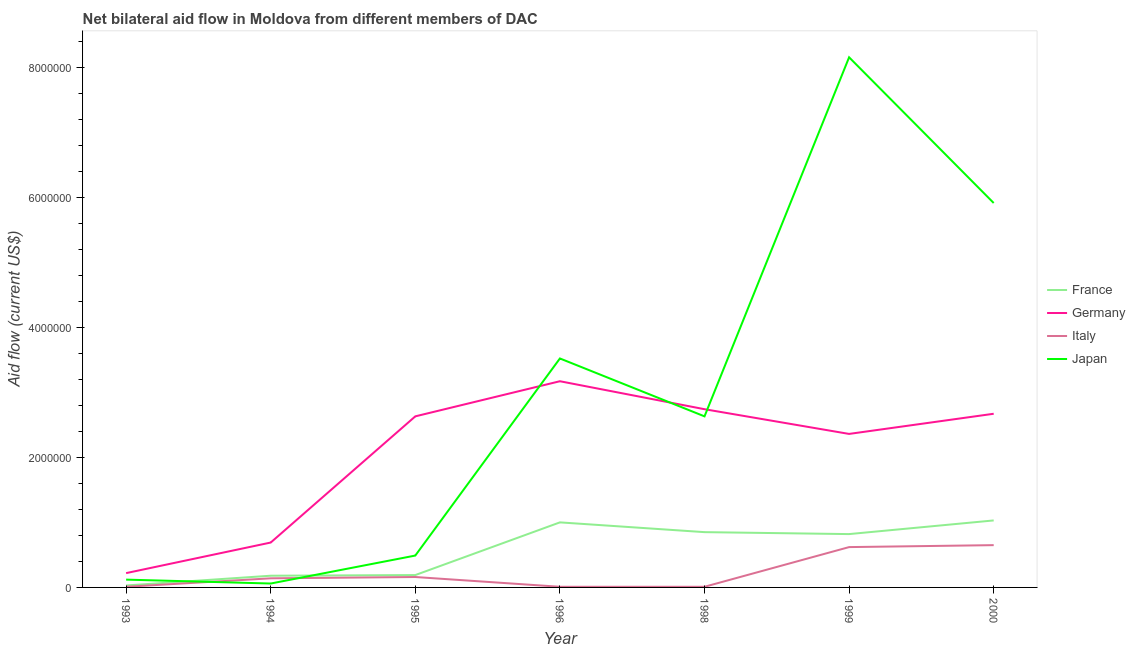What is the amount of aid given by france in 1996?
Ensure brevity in your answer.  1.00e+06. Across all years, what is the maximum amount of aid given by japan?
Your answer should be very brief. 8.15e+06. Across all years, what is the minimum amount of aid given by france?
Ensure brevity in your answer.  3.00e+04. In which year was the amount of aid given by italy maximum?
Offer a terse response. 2000. In which year was the amount of aid given by germany minimum?
Provide a succinct answer. 1993. What is the total amount of aid given by france in the graph?
Offer a terse response. 4.10e+06. What is the difference between the amount of aid given by germany in 1993 and that in 1999?
Provide a short and direct response. -2.14e+06. What is the difference between the amount of aid given by italy in 2000 and the amount of aid given by france in 1998?
Provide a succinct answer. -2.00e+05. What is the average amount of aid given by japan per year?
Your answer should be very brief. 2.98e+06. In the year 2000, what is the difference between the amount of aid given by france and amount of aid given by japan?
Provide a succinct answer. -4.88e+06. What is the ratio of the amount of aid given by germany in 1998 to that in 1999?
Your response must be concise. 1.16. What is the difference between the highest and the second highest amount of aid given by japan?
Your answer should be very brief. 2.24e+06. What is the difference between the highest and the lowest amount of aid given by germany?
Offer a terse response. 2.95e+06. In how many years, is the amount of aid given by france greater than the average amount of aid given by france taken over all years?
Ensure brevity in your answer.  4. Is the sum of the amount of aid given by france in 1996 and 1999 greater than the maximum amount of aid given by germany across all years?
Provide a succinct answer. No. Does the amount of aid given by italy monotonically increase over the years?
Your response must be concise. No. Is the amount of aid given by france strictly greater than the amount of aid given by japan over the years?
Give a very brief answer. No. How many years are there in the graph?
Make the answer very short. 7. What is the difference between two consecutive major ticks on the Y-axis?
Your response must be concise. 2.00e+06. Are the values on the major ticks of Y-axis written in scientific E-notation?
Make the answer very short. No. Does the graph contain any zero values?
Make the answer very short. No. Does the graph contain grids?
Your answer should be compact. No. Where does the legend appear in the graph?
Make the answer very short. Center right. How are the legend labels stacked?
Your response must be concise. Vertical. What is the title of the graph?
Give a very brief answer. Net bilateral aid flow in Moldova from different members of DAC. Does "CO2 damage" appear as one of the legend labels in the graph?
Your response must be concise. No. What is the Aid flow (current US$) of France in 1993?
Ensure brevity in your answer.  3.00e+04. What is the Aid flow (current US$) of Italy in 1993?
Offer a terse response. 10000. What is the Aid flow (current US$) of Japan in 1993?
Offer a terse response. 1.20e+05. What is the Aid flow (current US$) of Germany in 1994?
Ensure brevity in your answer.  6.90e+05. What is the Aid flow (current US$) of France in 1995?
Your response must be concise. 1.90e+05. What is the Aid flow (current US$) of Germany in 1995?
Offer a terse response. 2.63e+06. What is the Aid flow (current US$) in France in 1996?
Keep it short and to the point. 1.00e+06. What is the Aid flow (current US$) of Germany in 1996?
Your response must be concise. 3.17e+06. What is the Aid flow (current US$) of Italy in 1996?
Provide a succinct answer. 10000. What is the Aid flow (current US$) in Japan in 1996?
Your answer should be very brief. 3.52e+06. What is the Aid flow (current US$) of France in 1998?
Ensure brevity in your answer.  8.50e+05. What is the Aid flow (current US$) in Germany in 1998?
Offer a very short reply. 2.74e+06. What is the Aid flow (current US$) of Japan in 1998?
Offer a terse response. 2.63e+06. What is the Aid flow (current US$) in France in 1999?
Offer a terse response. 8.20e+05. What is the Aid flow (current US$) of Germany in 1999?
Give a very brief answer. 2.36e+06. What is the Aid flow (current US$) of Italy in 1999?
Provide a succinct answer. 6.20e+05. What is the Aid flow (current US$) of Japan in 1999?
Keep it short and to the point. 8.15e+06. What is the Aid flow (current US$) of France in 2000?
Make the answer very short. 1.03e+06. What is the Aid flow (current US$) of Germany in 2000?
Keep it short and to the point. 2.67e+06. What is the Aid flow (current US$) of Italy in 2000?
Your answer should be very brief. 6.50e+05. What is the Aid flow (current US$) of Japan in 2000?
Make the answer very short. 5.91e+06. Across all years, what is the maximum Aid flow (current US$) in France?
Your answer should be very brief. 1.03e+06. Across all years, what is the maximum Aid flow (current US$) in Germany?
Offer a very short reply. 3.17e+06. Across all years, what is the maximum Aid flow (current US$) in Italy?
Provide a short and direct response. 6.50e+05. Across all years, what is the maximum Aid flow (current US$) in Japan?
Offer a very short reply. 8.15e+06. Across all years, what is the minimum Aid flow (current US$) of Italy?
Provide a succinct answer. 10000. Across all years, what is the minimum Aid flow (current US$) of Japan?
Give a very brief answer. 6.00e+04. What is the total Aid flow (current US$) in France in the graph?
Offer a terse response. 4.10e+06. What is the total Aid flow (current US$) in Germany in the graph?
Keep it short and to the point. 1.45e+07. What is the total Aid flow (current US$) in Italy in the graph?
Give a very brief answer. 1.60e+06. What is the total Aid flow (current US$) in Japan in the graph?
Make the answer very short. 2.09e+07. What is the difference between the Aid flow (current US$) of France in 1993 and that in 1994?
Provide a short and direct response. -1.50e+05. What is the difference between the Aid flow (current US$) of Germany in 1993 and that in 1994?
Provide a succinct answer. -4.70e+05. What is the difference between the Aid flow (current US$) of Japan in 1993 and that in 1994?
Ensure brevity in your answer.  6.00e+04. What is the difference between the Aid flow (current US$) in Germany in 1993 and that in 1995?
Your answer should be very brief. -2.41e+06. What is the difference between the Aid flow (current US$) of Italy in 1993 and that in 1995?
Ensure brevity in your answer.  -1.50e+05. What is the difference between the Aid flow (current US$) in Japan in 1993 and that in 1995?
Your response must be concise. -3.70e+05. What is the difference between the Aid flow (current US$) in France in 1993 and that in 1996?
Offer a very short reply. -9.70e+05. What is the difference between the Aid flow (current US$) of Germany in 1993 and that in 1996?
Provide a succinct answer. -2.95e+06. What is the difference between the Aid flow (current US$) in Japan in 1993 and that in 1996?
Provide a short and direct response. -3.40e+06. What is the difference between the Aid flow (current US$) of France in 1993 and that in 1998?
Your response must be concise. -8.20e+05. What is the difference between the Aid flow (current US$) in Germany in 1993 and that in 1998?
Your response must be concise. -2.52e+06. What is the difference between the Aid flow (current US$) of Japan in 1993 and that in 1998?
Provide a succinct answer. -2.51e+06. What is the difference between the Aid flow (current US$) of France in 1993 and that in 1999?
Provide a short and direct response. -7.90e+05. What is the difference between the Aid flow (current US$) in Germany in 1993 and that in 1999?
Give a very brief answer. -2.14e+06. What is the difference between the Aid flow (current US$) of Italy in 1993 and that in 1999?
Offer a terse response. -6.10e+05. What is the difference between the Aid flow (current US$) of Japan in 1993 and that in 1999?
Provide a succinct answer. -8.03e+06. What is the difference between the Aid flow (current US$) of France in 1993 and that in 2000?
Provide a succinct answer. -1.00e+06. What is the difference between the Aid flow (current US$) in Germany in 1993 and that in 2000?
Offer a terse response. -2.45e+06. What is the difference between the Aid flow (current US$) of Italy in 1993 and that in 2000?
Make the answer very short. -6.40e+05. What is the difference between the Aid flow (current US$) in Japan in 1993 and that in 2000?
Provide a succinct answer. -5.79e+06. What is the difference between the Aid flow (current US$) of Germany in 1994 and that in 1995?
Ensure brevity in your answer.  -1.94e+06. What is the difference between the Aid flow (current US$) in Italy in 1994 and that in 1995?
Offer a very short reply. -2.00e+04. What is the difference between the Aid flow (current US$) of Japan in 1994 and that in 1995?
Your response must be concise. -4.30e+05. What is the difference between the Aid flow (current US$) in France in 1994 and that in 1996?
Provide a succinct answer. -8.20e+05. What is the difference between the Aid flow (current US$) in Germany in 1994 and that in 1996?
Your answer should be very brief. -2.48e+06. What is the difference between the Aid flow (current US$) of Japan in 1994 and that in 1996?
Offer a terse response. -3.46e+06. What is the difference between the Aid flow (current US$) of France in 1994 and that in 1998?
Provide a succinct answer. -6.70e+05. What is the difference between the Aid flow (current US$) in Germany in 1994 and that in 1998?
Keep it short and to the point. -2.05e+06. What is the difference between the Aid flow (current US$) in Japan in 1994 and that in 1998?
Your response must be concise. -2.57e+06. What is the difference between the Aid flow (current US$) of France in 1994 and that in 1999?
Your response must be concise. -6.40e+05. What is the difference between the Aid flow (current US$) in Germany in 1994 and that in 1999?
Your answer should be compact. -1.67e+06. What is the difference between the Aid flow (current US$) of Italy in 1994 and that in 1999?
Make the answer very short. -4.80e+05. What is the difference between the Aid flow (current US$) in Japan in 1994 and that in 1999?
Your response must be concise. -8.09e+06. What is the difference between the Aid flow (current US$) in France in 1994 and that in 2000?
Offer a very short reply. -8.50e+05. What is the difference between the Aid flow (current US$) of Germany in 1994 and that in 2000?
Make the answer very short. -1.98e+06. What is the difference between the Aid flow (current US$) in Italy in 1994 and that in 2000?
Your answer should be very brief. -5.10e+05. What is the difference between the Aid flow (current US$) of Japan in 1994 and that in 2000?
Offer a very short reply. -5.85e+06. What is the difference between the Aid flow (current US$) of France in 1995 and that in 1996?
Your response must be concise. -8.10e+05. What is the difference between the Aid flow (current US$) in Germany in 1995 and that in 1996?
Give a very brief answer. -5.40e+05. What is the difference between the Aid flow (current US$) in Italy in 1995 and that in 1996?
Provide a short and direct response. 1.50e+05. What is the difference between the Aid flow (current US$) of Japan in 1995 and that in 1996?
Offer a terse response. -3.03e+06. What is the difference between the Aid flow (current US$) of France in 1995 and that in 1998?
Provide a short and direct response. -6.60e+05. What is the difference between the Aid flow (current US$) of Japan in 1995 and that in 1998?
Offer a terse response. -2.14e+06. What is the difference between the Aid flow (current US$) of France in 1995 and that in 1999?
Your response must be concise. -6.30e+05. What is the difference between the Aid flow (current US$) of Germany in 1995 and that in 1999?
Your answer should be compact. 2.70e+05. What is the difference between the Aid flow (current US$) of Italy in 1995 and that in 1999?
Your response must be concise. -4.60e+05. What is the difference between the Aid flow (current US$) of Japan in 1995 and that in 1999?
Your answer should be very brief. -7.66e+06. What is the difference between the Aid flow (current US$) of France in 1995 and that in 2000?
Ensure brevity in your answer.  -8.40e+05. What is the difference between the Aid flow (current US$) of Italy in 1995 and that in 2000?
Ensure brevity in your answer.  -4.90e+05. What is the difference between the Aid flow (current US$) in Japan in 1995 and that in 2000?
Your response must be concise. -5.42e+06. What is the difference between the Aid flow (current US$) of Germany in 1996 and that in 1998?
Keep it short and to the point. 4.30e+05. What is the difference between the Aid flow (current US$) in Italy in 1996 and that in 1998?
Offer a very short reply. 0. What is the difference between the Aid flow (current US$) of Japan in 1996 and that in 1998?
Your answer should be compact. 8.90e+05. What is the difference between the Aid flow (current US$) in Germany in 1996 and that in 1999?
Keep it short and to the point. 8.10e+05. What is the difference between the Aid flow (current US$) in Italy in 1996 and that in 1999?
Offer a terse response. -6.10e+05. What is the difference between the Aid flow (current US$) of Japan in 1996 and that in 1999?
Your response must be concise. -4.63e+06. What is the difference between the Aid flow (current US$) of France in 1996 and that in 2000?
Offer a very short reply. -3.00e+04. What is the difference between the Aid flow (current US$) of Italy in 1996 and that in 2000?
Offer a terse response. -6.40e+05. What is the difference between the Aid flow (current US$) in Japan in 1996 and that in 2000?
Provide a short and direct response. -2.39e+06. What is the difference between the Aid flow (current US$) of France in 1998 and that in 1999?
Offer a terse response. 3.00e+04. What is the difference between the Aid flow (current US$) in Italy in 1998 and that in 1999?
Provide a succinct answer. -6.10e+05. What is the difference between the Aid flow (current US$) of Japan in 1998 and that in 1999?
Give a very brief answer. -5.52e+06. What is the difference between the Aid flow (current US$) of Germany in 1998 and that in 2000?
Provide a short and direct response. 7.00e+04. What is the difference between the Aid flow (current US$) of Italy in 1998 and that in 2000?
Provide a succinct answer. -6.40e+05. What is the difference between the Aid flow (current US$) of Japan in 1998 and that in 2000?
Make the answer very short. -3.28e+06. What is the difference between the Aid flow (current US$) in Germany in 1999 and that in 2000?
Keep it short and to the point. -3.10e+05. What is the difference between the Aid flow (current US$) in Italy in 1999 and that in 2000?
Make the answer very short. -3.00e+04. What is the difference between the Aid flow (current US$) of Japan in 1999 and that in 2000?
Offer a very short reply. 2.24e+06. What is the difference between the Aid flow (current US$) of France in 1993 and the Aid flow (current US$) of Germany in 1994?
Provide a succinct answer. -6.60e+05. What is the difference between the Aid flow (current US$) in France in 1993 and the Aid flow (current US$) in Japan in 1994?
Provide a short and direct response. -3.00e+04. What is the difference between the Aid flow (current US$) in Germany in 1993 and the Aid flow (current US$) in Japan in 1994?
Provide a short and direct response. 1.60e+05. What is the difference between the Aid flow (current US$) in France in 1993 and the Aid flow (current US$) in Germany in 1995?
Make the answer very short. -2.60e+06. What is the difference between the Aid flow (current US$) in France in 1993 and the Aid flow (current US$) in Japan in 1995?
Ensure brevity in your answer.  -4.60e+05. What is the difference between the Aid flow (current US$) in Italy in 1993 and the Aid flow (current US$) in Japan in 1995?
Your answer should be compact. -4.80e+05. What is the difference between the Aid flow (current US$) of France in 1993 and the Aid flow (current US$) of Germany in 1996?
Offer a terse response. -3.14e+06. What is the difference between the Aid flow (current US$) in France in 1993 and the Aid flow (current US$) in Japan in 1996?
Your answer should be compact. -3.49e+06. What is the difference between the Aid flow (current US$) in Germany in 1993 and the Aid flow (current US$) in Italy in 1996?
Offer a very short reply. 2.10e+05. What is the difference between the Aid flow (current US$) of Germany in 1993 and the Aid flow (current US$) of Japan in 1996?
Give a very brief answer. -3.30e+06. What is the difference between the Aid flow (current US$) of Italy in 1993 and the Aid flow (current US$) of Japan in 1996?
Give a very brief answer. -3.51e+06. What is the difference between the Aid flow (current US$) of France in 1993 and the Aid flow (current US$) of Germany in 1998?
Provide a succinct answer. -2.71e+06. What is the difference between the Aid flow (current US$) in France in 1993 and the Aid flow (current US$) in Japan in 1998?
Your answer should be very brief. -2.60e+06. What is the difference between the Aid flow (current US$) in Germany in 1993 and the Aid flow (current US$) in Japan in 1998?
Provide a short and direct response. -2.41e+06. What is the difference between the Aid flow (current US$) in Italy in 1993 and the Aid flow (current US$) in Japan in 1998?
Keep it short and to the point. -2.62e+06. What is the difference between the Aid flow (current US$) in France in 1993 and the Aid flow (current US$) in Germany in 1999?
Offer a very short reply. -2.33e+06. What is the difference between the Aid flow (current US$) of France in 1993 and the Aid flow (current US$) of Italy in 1999?
Your response must be concise. -5.90e+05. What is the difference between the Aid flow (current US$) of France in 1993 and the Aid flow (current US$) of Japan in 1999?
Offer a very short reply. -8.12e+06. What is the difference between the Aid flow (current US$) of Germany in 1993 and the Aid flow (current US$) of Italy in 1999?
Provide a short and direct response. -4.00e+05. What is the difference between the Aid flow (current US$) of Germany in 1993 and the Aid flow (current US$) of Japan in 1999?
Your answer should be compact. -7.93e+06. What is the difference between the Aid flow (current US$) in Italy in 1993 and the Aid flow (current US$) in Japan in 1999?
Give a very brief answer. -8.14e+06. What is the difference between the Aid flow (current US$) of France in 1993 and the Aid flow (current US$) of Germany in 2000?
Provide a short and direct response. -2.64e+06. What is the difference between the Aid flow (current US$) in France in 1993 and the Aid flow (current US$) in Italy in 2000?
Provide a short and direct response. -6.20e+05. What is the difference between the Aid flow (current US$) in France in 1993 and the Aid flow (current US$) in Japan in 2000?
Offer a terse response. -5.88e+06. What is the difference between the Aid flow (current US$) of Germany in 1993 and the Aid flow (current US$) of Italy in 2000?
Make the answer very short. -4.30e+05. What is the difference between the Aid flow (current US$) in Germany in 1993 and the Aid flow (current US$) in Japan in 2000?
Provide a short and direct response. -5.69e+06. What is the difference between the Aid flow (current US$) of Italy in 1993 and the Aid flow (current US$) of Japan in 2000?
Ensure brevity in your answer.  -5.90e+06. What is the difference between the Aid flow (current US$) in France in 1994 and the Aid flow (current US$) in Germany in 1995?
Make the answer very short. -2.45e+06. What is the difference between the Aid flow (current US$) in France in 1994 and the Aid flow (current US$) in Japan in 1995?
Provide a succinct answer. -3.10e+05. What is the difference between the Aid flow (current US$) of Germany in 1994 and the Aid flow (current US$) of Italy in 1995?
Keep it short and to the point. 5.30e+05. What is the difference between the Aid flow (current US$) in Germany in 1994 and the Aid flow (current US$) in Japan in 1995?
Your response must be concise. 2.00e+05. What is the difference between the Aid flow (current US$) of Italy in 1994 and the Aid flow (current US$) of Japan in 1995?
Make the answer very short. -3.50e+05. What is the difference between the Aid flow (current US$) of France in 1994 and the Aid flow (current US$) of Germany in 1996?
Offer a terse response. -2.99e+06. What is the difference between the Aid flow (current US$) in France in 1994 and the Aid flow (current US$) in Japan in 1996?
Provide a succinct answer. -3.34e+06. What is the difference between the Aid flow (current US$) of Germany in 1994 and the Aid flow (current US$) of Italy in 1996?
Offer a very short reply. 6.80e+05. What is the difference between the Aid flow (current US$) in Germany in 1994 and the Aid flow (current US$) in Japan in 1996?
Offer a very short reply. -2.83e+06. What is the difference between the Aid flow (current US$) in Italy in 1994 and the Aid flow (current US$) in Japan in 1996?
Your response must be concise. -3.38e+06. What is the difference between the Aid flow (current US$) in France in 1994 and the Aid flow (current US$) in Germany in 1998?
Provide a succinct answer. -2.56e+06. What is the difference between the Aid flow (current US$) of France in 1994 and the Aid flow (current US$) of Japan in 1998?
Your answer should be very brief. -2.45e+06. What is the difference between the Aid flow (current US$) of Germany in 1994 and the Aid flow (current US$) of Italy in 1998?
Your answer should be very brief. 6.80e+05. What is the difference between the Aid flow (current US$) of Germany in 1994 and the Aid flow (current US$) of Japan in 1998?
Offer a terse response. -1.94e+06. What is the difference between the Aid flow (current US$) in Italy in 1994 and the Aid flow (current US$) in Japan in 1998?
Your answer should be compact. -2.49e+06. What is the difference between the Aid flow (current US$) of France in 1994 and the Aid flow (current US$) of Germany in 1999?
Your answer should be compact. -2.18e+06. What is the difference between the Aid flow (current US$) in France in 1994 and the Aid flow (current US$) in Italy in 1999?
Your response must be concise. -4.40e+05. What is the difference between the Aid flow (current US$) in France in 1994 and the Aid flow (current US$) in Japan in 1999?
Give a very brief answer. -7.97e+06. What is the difference between the Aid flow (current US$) in Germany in 1994 and the Aid flow (current US$) in Japan in 1999?
Make the answer very short. -7.46e+06. What is the difference between the Aid flow (current US$) of Italy in 1994 and the Aid flow (current US$) of Japan in 1999?
Ensure brevity in your answer.  -8.01e+06. What is the difference between the Aid flow (current US$) in France in 1994 and the Aid flow (current US$) in Germany in 2000?
Keep it short and to the point. -2.49e+06. What is the difference between the Aid flow (current US$) of France in 1994 and the Aid flow (current US$) of Italy in 2000?
Your answer should be very brief. -4.70e+05. What is the difference between the Aid flow (current US$) in France in 1994 and the Aid flow (current US$) in Japan in 2000?
Your response must be concise. -5.73e+06. What is the difference between the Aid flow (current US$) in Germany in 1994 and the Aid flow (current US$) in Japan in 2000?
Offer a terse response. -5.22e+06. What is the difference between the Aid flow (current US$) of Italy in 1994 and the Aid flow (current US$) of Japan in 2000?
Provide a succinct answer. -5.77e+06. What is the difference between the Aid flow (current US$) of France in 1995 and the Aid flow (current US$) of Germany in 1996?
Your response must be concise. -2.98e+06. What is the difference between the Aid flow (current US$) of France in 1995 and the Aid flow (current US$) of Japan in 1996?
Offer a very short reply. -3.33e+06. What is the difference between the Aid flow (current US$) of Germany in 1995 and the Aid flow (current US$) of Italy in 1996?
Your answer should be very brief. 2.62e+06. What is the difference between the Aid flow (current US$) of Germany in 1995 and the Aid flow (current US$) of Japan in 1996?
Your answer should be very brief. -8.90e+05. What is the difference between the Aid flow (current US$) of Italy in 1995 and the Aid flow (current US$) of Japan in 1996?
Your answer should be compact. -3.36e+06. What is the difference between the Aid flow (current US$) of France in 1995 and the Aid flow (current US$) of Germany in 1998?
Your answer should be compact. -2.55e+06. What is the difference between the Aid flow (current US$) in France in 1995 and the Aid flow (current US$) in Japan in 1998?
Ensure brevity in your answer.  -2.44e+06. What is the difference between the Aid flow (current US$) in Germany in 1995 and the Aid flow (current US$) in Italy in 1998?
Offer a terse response. 2.62e+06. What is the difference between the Aid flow (current US$) of Germany in 1995 and the Aid flow (current US$) of Japan in 1998?
Provide a succinct answer. 0. What is the difference between the Aid flow (current US$) of Italy in 1995 and the Aid flow (current US$) of Japan in 1998?
Offer a very short reply. -2.47e+06. What is the difference between the Aid flow (current US$) of France in 1995 and the Aid flow (current US$) of Germany in 1999?
Your answer should be compact. -2.17e+06. What is the difference between the Aid flow (current US$) of France in 1995 and the Aid flow (current US$) of Italy in 1999?
Your answer should be compact. -4.30e+05. What is the difference between the Aid flow (current US$) of France in 1995 and the Aid flow (current US$) of Japan in 1999?
Keep it short and to the point. -7.96e+06. What is the difference between the Aid flow (current US$) in Germany in 1995 and the Aid flow (current US$) in Italy in 1999?
Provide a succinct answer. 2.01e+06. What is the difference between the Aid flow (current US$) in Germany in 1995 and the Aid flow (current US$) in Japan in 1999?
Offer a terse response. -5.52e+06. What is the difference between the Aid flow (current US$) of Italy in 1995 and the Aid flow (current US$) of Japan in 1999?
Offer a very short reply. -7.99e+06. What is the difference between the Aid flow (current US$) of France in 1995 and the Aid flow (current US$) of Germany in 2000?
Your response must be concise. -2.48e+06. What is the difference between the Aid flow (current US$) of France in 1995 and the Aid flow (current US$) of Italy in 2000?
Make the answer very short. -4.60e+05. What is the difference between the Aid flow (current US$) in France in 1995 and the Aid flow (current US$) in Japan in 2000?
Offer a terse response. -5.72e+06. What is the difference between the Aid flow (current US$) in Germany in 1995 and the Aid flow (current US$) in Italy in 2000?
Your response must be concise. 1.98e+06. What is the difference between the Aid flow (current US$) in Germany in 1995 and the Aid flow (current US$) in Japan in 2000?
Offer a very short reply. -3.28e+06. What is the difference between the Aid flow (current US$) of Italy in 1995 and the Aid flow (current US$) of Japan in 2000?
Ensure brevity in your answer.  -5.75e+06. What is the difference between the Aid flow (current US$) of France in 1996 and the Aid flow (current US$) of Germany in 1998?
Make the answer very short. -1.74e+06. What is the difference between the Aid flow (current US$) in France in 1996 and the Aid flow (current US$) in Italy in 1998?
Offer a very short reply. 9.90e+05. What is the difference between the Aid flow (current US$) in France in 1996 and the Aid flow (current US$) in Japan in 1998?
Give a very brief answer. -1.63e+06. What is the difference between the Aid flow (current US$) in Germany in 1996 and the Aid flow (current US$) in Italy in 1998?
Your response must be concise. 3.16e+06. What is the difference between the Aid flow (current US$) of Germany in 1996 and the Aid flow (current US$) of Japan in 1998?
Your answer should be very brief. 5.40e+05. What is the difference between the Aid flow (current US$) in Italy in 1996 and the Aid flow (current US$) in Japan in 1998?
Give a very brief answer. -2.62e+06. What is the difference between the Aid flow (current US$) of France in 1996 and the Aid flow (current US$) of Germany in 1999?
Give a very brief answer. -1.36e+06. What is the difference between the Aid flow (current US$) of France in 1996 and the Aid flow (current US$) of Japan in 1999?
Provide a short and direct response. -7.15e+06. What is the difference between the Aid flow (current US$) of Germany in 1996 and the Aid flow (current US$) of Italy in 1999?
Give a very brief answer. 2.55e+06. What is the difference between the Aid flow (current US$) of Germany in 1996 and the Aid flow (current US$) of Japan in 1999?
Make the answer very short. -4.98e+06. What is the difference between the Aid flow (current US$) of Italy in 1996 and the Aid flow (current US$) of Japan in 1999?
Provide a succinct answer. -8.14e+06. What is the difference between the Aid flow (current US$) of France in 1996 and the Aid flow (current US$) of Germany in 2000?
Your answer should be compact. -1.67e+06. What is the difference between the Aid flow (current US$) in France in 1996 and the Aid flow (current US$) in Italy in 2000?
Your answer should be very brief. 3.50e+05. What is the difference between the Aid flow (current US$) in France in 1996 and the Aid flow (current US$) in Japan in 2000?
Your answer should be compact. -4.91e+06. What is the difference between the Aid flow (current US$) of Germany in 1996 and the Aid flow (current US$) of Italy in 2000?
Provide a succinct answer. 2.52e+06. What is the difference between the Aid flow (current US$) of Germany in 1996 and the Aid flow (current US$) of Japan in 2000?
Make the answer very short. -2.74e+06. What is the difference between the Aid flow (current US$) of Italy in 1996 and the Aid flow (current US$) of Japan in 2000?
Make the answer very short. -5.90e+06. What is the difference between the Aid flow (current US$) in France in 1998 and the Aid flow (current US$) in Germany in 1999?
Offer a very short reply. -1.51e+06. What is the difference between the Aid flow (current US$) of France in 1998 and the Aid flow (current US$) of Italy in 1999?
Keep it short and to the point. 2.30e+05. What is the difference between the Aid flow (current US$) in France in 1998 and the Aid flow (current US$) in Japan in 1999?
Ensure brevity in your answer.  -7.30e+06. What is the difference between the Aid flow (current US$) of Germany in 1998 and the Aid flow (current US$) of Italy in 1999?
Your answer should be compact. 2.12e+06. What is the difference between the Aid flow (current US$) in Germany in 1998 and the Aid flow (current US$) in Japan in 1999?
Provide a succinct answer. -5.41e+06. What is the difference between the Aid flow (current US$) in Italy in 1998 and the Aid flow (current US$) in Japan in 1999?
Offer a terse response. -8.14e+06. What is the difference between the Aid flow (current US$) of France in 1998 and the Aid flow (current US$) of Germany in 2000?
Give a very brief answer. -1.82e+06. What is the difference between the Aid flow (current US$) in France in 1998 and the Aid flow (current US$) in Italy in 2000?
Your response must be concise. 2.00e+05. What is the difference between the Aid flow (current US$) of France in 1998 and the Aid flow (current US$) of Japan in 2000?
Make the answer very short. -5.06e+06. What is the difference between the Aid flow (current US$) of Germany in 1998 and the Aid flow (current US$) of Italy in 2000?
Your answer should be compact. 2.09e+06. What is the difference between the Aid flow (current US$) of Germany in 1998 and the Aid flow (current US$) of Japan in 2000?
Offer a terse response. -3.17e+06. What is the difference between the Aid flow (current US$) of Italy in 1998 and the Aid flow (current US$) of Japan in 2000?
Offer a very short reply. -5.90e+06. What is the difference between the Aid flow (current US$) of France in 1999 and the Aid flow (current US$) of Germany in 2000?
Keep it short and to the point. -1.85e+06. What is the difference between the Aid flow (current US$) in France in 1999 and the Aid flow (current US$) in Italy in 2000?
Provide a succinct answer. 1.70e+05. What is the difference between the Aid flow (current US$) in France in 1999 and the Aid flow (current US$) in Japan in 2000?
Provide a short and direct response. -5.09e+06. What is the difference between the Aid flow (current US$) in Germany in 1999 and the Aid flow (current US$) in Italy in 2000?
Offer a very short reply. 1.71e+06. What is the difference between the Aid flow (current US$) of Germany in 1999 and the Aid flow (current US$) of Japan in 2000?
Provide a short and direct response. -3.55e+06. What is the difference between the Aid flow (current US$) in Italy in 1999 and the Aid flow (current US$) in Japan in 2000?
Offer a very short reply. -5.29e+06. What is the average Aid flow (current US$) in France per year?
Provide a short and direct response. 5.86e+05. What is the average Aid flow (current US$) of Germany per year?
Provide a short and direct response. 2.07e+06. What is the average Aid flow (current US$) of Italy per year?
Give a very brief answer. 2.29e+05. What is the average Aid flow (current US$) in Japan per year?
Offer a very short reply. 2.98e+06. In the year 1993, what is the difference between the Aid flow (current US$) of France and Aid flow (current US$) of Japan?
Your response must be concise. -9.00e+04. In the year 1993, what is the difference between the Aid flow (current US$) of Germany and Aid flow (current US$) of Italy?
Keep it short and to the point. 2.10e+05. In the year 1993, what is the difference between the Aid flow (current US$) of Italy and Aid flow (current US$) of Japan?
Offer a very short reply. -1.10e+05. In the year 1994, what is the difference between the Aid flow (current US$) in France and Aid flow (current US$) in Germany?
Give a very brief answer. -5.10e+05. In the year 1994, what is the difference between the Aid flow (current US$) of France and Aid flow (current US$) of Italy?
Ensure brevity in your answer.  4.00e+04. In the year 1994, what is the difference between the Aid flow (current US$) in Germany and Aid flow (current US$) in Italy?
Ensure brevity in your answer.  5.50e+05. In the year 1994, what is the difference between the Aid flow (current US$) in Germany and Aid flow (current US$) in Japan?
Provide a short and direct response. 6.30e+05. In the year 1994, what is the difference between the Aid flow (current US$) of Italy and Aid flow (current US$) of Japan?
Ensure brevity in your answer.  8.00e+04. In the year 1995, what is the difference between the Aid flow (current US$) in France and Aid flow (current US$) in Germany?
Make the answer very short. -2.44e+06. In the year 1995, what is the difference between the Aid flow (current US$) in France and Aid flow (current US$) in Italy?
Give a very brief answer. 3.00e+04. In the year 1995, what is the difference between the Aid flow (current US$) in France and Aid flow (current US$) in Japan?
Your answer should be compact. -3.00e+05. In the year 1995, what is the difference between the Aid flow (current US$) of Germany and Aid flow (current US$) of Italy?
Provide a succinct answer. 2.47e+06. In the year 1995, what is the difference between the Aid flow (current US$) in Germany and Aid flow (current US$) in Japan?
Offer a very short reply. 2.14e+06. In the year 1995, what is the difference between the Aid flow (current US$) of Italy and Aid flow (current US$) of Japan?
Give a very brief answer. -3.30e+05. In the year 1996, what is the difference between the Aid flow (current US$) of France and Aid flow (current US$) of Germany?
Your response must be concise. -2.17e+06. In the year 1996, what is the difference between the Aid flow (current US$) of France and Aid flow (current US$) of Italy?
Provide a short and direct response. 9.90e+05. In the year 1996, what is the difference between the Aid flow (current US$) of France and Aid flow (current US$) of Japan?
Your response must be concise. -2.52e+06. In the year 1996, what is the difference between the Aid flow (current US$) in Germany and Aid flow (current US$) in Italy?
Your answer should be compact. 3.16e+06. In the year 1996, what is the difference between the Aid flow (current US$) of Germany and Aid flow (current US$) of Japan?
Give a very brief answer. -3.50e+05. In the year 1996, what is the difference between the Aid flow (current US$) of Italy and Aid flow (current US$) of Japan?
Offer a very short reply. -3.51e+06. In the year 1998, what is the difference between the Aid flow (current US$) of France and Aid flow (current US$) of Germany?
Make the answer very short. -1.89e+06. In the year 1998, what is the difference between the Aid flow (current US$) of France and Aid flow (current US$) of Italy?
Your answer should be compact. 8.40e+05. In the year 1998, what is the difference between the Aid flow (current US$) in France and Aid flow (current US$) in Japan?
Your response must be concise. -1.78e+06. In the year 1998, what is the difference between the Aid flow (current US$) of Germany and Aid flow (current US$) of Italy?
Offer a terse response. 2.73e+06. In the year 1998, what is the difference between the Aid flow (current US$) in Germany and Aid flow (current US$) in Japan?
Make the answer very short. 1.10e+05. In the year 1998, what is the difference between the Aid flow (current US$) of Italy and Aid flow (current US$) of Japan?
Ensure brevity in your answer.  -2.62e+06. In the year 1999, what is the difference between the Aid flow (current US$) of France and Aid flow (current US$) of Germany?
Provide a succinct answer. -1.54e+06. In the year 1999, what is the difference between the Aid flow (current US$) of France and Aid flow (current US$) of Italy?
Provide a short and direct response. 2.00e+05. In the year 1999, what is the difference between the Aid flow (current US$) of France and Aid flow (current US$) of Japan?
Keep it short and to the point. -7.33e+06. In the year 1999, what is the difference between the Aid flow (current US$) in Germany and Aid flow (current US$) in Italy?
Offer a very short reply. 1.74e+06. In the year 1999, what is the difference between the Aid flow (current US$) in Germany and Aid flow (current US$) in Japan?
Your answer should be compact. -5.79e+06. In the year 1999, what is the difference between the Aid flow (current US$) of Italy and Aid flow (current US$) of Japan?
Provide a short and direct response. -7.53e+06. In the year 2000, what is the difference between the Aid flow (current US$) in France and Aid flow (current US$) in Germany?
Offer a terse response. -1.64e+06. In the year 2000, what is the difference between the Aid flow (current US$) in France and Aid flow (current US$) in Japan?
Provide a short and direct response. -4.88e+06. In the year 2000, what is the difference between the Aid flow (current US$) in Germany and Aid flow (current US$) in Italy?
Offer a very short reply. 2.02e+06. In the year 2000, what is the difference between the Aid flow (current US$) of Germany and Aid flow (current US$) of Japan?
Your answer should be compact. -3.24e+06. In the year 2000, what is the difference between the Aid flow (current US$) of Italy and Aid flow (current US$) of Japan?
Offer a very short reply. -5.26e+06. What is the ratio of the Aid flow (current US$) in Germany in 1993 to that in 1994?
Make the answer very short. 0.32. What is the ratio of the Aid flow (current US$) in Italy in 1993 to that in 1994?
Keep it short and to the point. 0.07. What is the ratio of the Aid flow (current US$) in Japan in 1993 to that in 1994?
Ensure brevity in your answer.  2. What is the ratio of the Aid flow (current US$) of France in 1993 to that in 1995?
Provide a short and direct response. 0.16. What is the ratio of the Aid flow (current US$) in Germany in 1993 to that in 1995?
Provide a short and direct response. 0.08. What is the ratio of the Aid flow (current US$) in Italy in 1993 to that in 1995?
Provide a short and direct response. 0.06. What is the ratio of the Aid flow (current US$) in Japan in 1993 to that in 1995?
Keep it short and to the point. 0.24. What is the ratio of the Aid flow (current US$) of France in 1993 to that in 1996?
Offer a terse response. 0.03. What is the ratio of the Aid flow (current US$) of Germany in 1993 to that in 1996?
Your response must be concise. 0.07. What is the ratio of the Aid flow (current US$) of Italy in 1993 to that in 1996?
Offer a very short reply. 1. What is the ratio of the Aid flow (current US$) of Japan in 1993 to that in 1996?
Your answer should be compact. 0.03. What is the ratio of the Aid flow (current US$) in France in 1993 to that in 1998?
Ensure brevity in your answer.  0.04. What is the ratio of the Aid flow (current US$) of Germany in 1993 to that in 1998?
Your answer should be very brief. 0.08. What is the ratio of the Aid flow (current US$) of Japan in 1993 to that in 1998?
Offer a very short reply. 0.05. What is the ratio of the Aid flow (current US$) in France in 1993 to that in 1999?
Your answer should be very brief. 0.04. What is the ratio of the Aid flow (current US$) in Germany in 1993 to that in 1999?
Provide a short and direct response. 0.09. What is the ratio of the Aid flow (current US$) of Italy in 1993 to that in 1999?
Your answer should be compact. 0.02. What is the ratio of the Aid flow (current US$) in Japan in 1993 to that in 1999?
Your response must be concise. 0.01. What is the ratio of the Aid flow (current US$) of France in 1993 to that in 2000?
Keep it short and to the point. 0.03. What is the ratio of the Aid flow (current US$) of Germany in 1993 to that in 2000?
Make the answer very short. 0.08. What is the ratio of the Aid flow (current US$) in Italy in 1993 to that in 2000?
Offer a very short reply. 0.02. What is the ratio of the Aid flow (current US$) in Japan in 1993 to that in 2000?
Your answer should be compact. 0.02. What is the ratio of the Aid flow (current US$) of France in 1994 to that in 1995?
Ensure brevity in your answer.  0.95. What is the ratio of the Aid flow (current US$) in Germany in 1994 to that in 1995?
Offer a terse response. 0.26. What is the ratio of the Aid flow (current US$) in Italy in 1994 to that in 1995?
Make the answer very short. 0.88. What is the ratio of the Aid flow (current US$) of Japan in 1994 to that in 1995?
Keep it short and to the point. 0.12. What is the ratio of the Aid flow (current US$) of France in 1994 to that in 1996?
Offer a very short reply. 0.18. What is the ratio of the Aid flow (current US$) of Germany in 1994 to that in 1996?
Make the answer very short. 0.22. What is the ratio of the Aid flow (current US$) in Japan in 1994 to that in 1996?
Offer a terse response. 0.02. What is the ratio of the Aid flow (current US$) in France in 1994 to that in 1998?
Your answer should be very brief. 0.21. What is the ratio of the Aid flow (current US$) of Germany in 1994 to that in 1998?
Ensure brevity in your answer.  0.25. What is the ratio of the Aid flow (current US$) in Japan in 1994 to that in 1998?
Make the answer very short. 0.02. What is the ratio of the Aid flow (current US$) of France in 1994 to that in 1999?
Your answer should be very brief. 0.22. What is the ratio of the Aid flow (current US$) in Germany in 1994 to that in 1999?
Provide a succinct answer. 0.29. What is the ratio of the Aid flow (current US$) in Italy in 1994 to that in 1999?
Your answer should be very brief. 0.23. What is the ratio of the Aid flow (current US$) of Japan in 1994 to that in 1999?
Keep it short and to the point. 0.01. What is the ratio of the Aid flow (current US$) of France in 1994 to that in 2000?
Offer a terse response. 0.17. What is the ratio of the Aid flow (current US$) of Germany in 1994 to that in 2000?
Provide a succinct answer. 0.26. What is the ratio of the Aid flow (current US$) in Italy in 1994 to that in 2000?
Ensure brevity in your answer.  0.22. What is the ratio of the Aid flow (current US$) of Japan in 1994 to that in 2000?
Offer a very short reply. 0.01. What is the ratio of the Aid flow (current US$) of France in 1995 to that in 1996?
Keep it short and to the point. 0.19. What is the ratio of the Aid flow (current US$) of Germany in 1995 to that in 1996?
Keep it short and to the point. 0.83. What is the ratio of the Aid flow (current US$) in Italy in 1995 to that in 1996?
Offer a terse response. 16. What is the ratio of the Aid flow (current US$) in Japan in 1995 to that in 1996?
Keep it short and to the point. 0.14. What is the ratio of the Aid flow (current US$) in France in 1995 to that in 1998?
Your response must be concise. 0.22. What is the ratio of the Aid flow (current US$) in Germany in 1995 to that in 1998?
Your answer should be compact. 0.96. What is the ratio of the Aid flow (current US$) in Italy in 1995 to that in 1998?
Keep it short and to the point. 16. What is the ratio of the Aid flow (current US$) in Japan in 1995 to that in 1998?
Your answer should be compact. 0.19. What is the ratio of the Aid flow (current US$) of France in 1995 to that in 1999?
Offer a very short reply. 0.23. What is the ratio of the Aid flow (current US$) of Germany in 1995 to that in 1999?
Give a very brief answer. 1.11. What is the ratio of the Aid flow (current US$) in Italy in 1995 to that in 1999?
Provide a succinct answer. 0.26. What is the ratio of the Aid flow (current US$) in Japan in 1995 to that in 1999?
Your response must be concise. 0.06. What is the ratio of the Aid flow (current US$) of France in 1995 to that in 2000?
Give a very brief answer. 0.18. What is the ratio of the Aid flow (current US$) in Germany in 1995 to that in 2000?
Your answer should be compact. 0.98. What is the ratio of the Aid flow (current US$) of Italy in 1995 to that in 2000?
Ensure brevity in your answer.  0.25. What is the ratio of the Aid flow (current US$) of Japan in 1995 to that in 2000?
Your answer should be very brief. 0.08. What is the ratio of the Aid flow (current US$) of France in 1996 to that in 1998?
Make the answer very short. 1.18. What is the ratio of the Aid flow (current US$) in Germany in 1996 to that in 1998?
Your answer should be compact. 1.16. What is the ratio of the Aid flow (current US$) of Italy in 1996 to that in 1998?
Provide a succinct answer. 1. What is the ratio of the Aid flow (current US$) of Japan in 1996 to that in 1998?
Offer a terse response. 1.34. What is the ratio of the Aid flow (current US$) of France in 1996 to that in 1999?
Ensure brevity in your answer.  1.22. What is the ratio of the Aid flow (current US$) of Germany in 1996 to that in 1999?
Your answer should be very brief. 1.34. What is the ratio of the Aid flow (current US$) of Italy in 1996 to that in 1999?
Your answer should be compact. 0.02. What is the ratio of the Aid flow (current US$) of Japan in 1996 to that in 1999?
Keep it short and to the point. 0.43. What is the ratio of the Aid flow (current US$) in France in 1996 to that in 2000?
Your response must be concise. 0.97. What is the ratio of the Aid flow (current US$) in Germany in 1996 to that in 2000?
Your answer should be very brief. 1.19. What is the ratio of the Aid flow (current US$) of Italy in 1996 to that in 2000?
Offer a very short reply. 0.02. What is the ratio of the Aid flow (current US$) in Japan in 1996 to that in 2000?
Ensure brevity in your answer.  0.6. What is the ratio of the Aid flow (current US$) of France in 1998 to that in 1999?
Your answer should be very brief. 1.04. What is the ratio of the Aid flow (current US$) in Germany in 1998 to that in 1999?
Provide a short and direct response. 1.16. What is the ratio of the Aid flow (current US$) in Italy in 1998 to that in 1999?
Your answer should be compact. 0.02. What is the ratio of the Aid flow (current US$) of Japan in 1998 to that in 1999?
Ensure brevity in your answer.  0.32. What is the ratio of the Aid flow (current US$) of France in 1998 to that in 2000?
Offer a terse response. 0.83. What is the ratio of the Aid flow (current US$) of Germany in 1998 to that in 2000?
Your response must be concise. 1.03. What is the ratio of the Aid flow (current US$) of Italy in 1998 to that in 2000?
Provide a short and direct response. 0.02. What is the ratio of the Aid flow (current US$) of Japan in 1998 to that in 2000?
Offer a very short reply. 0.45. What is the ratio of the Aid flow (current US$) of France in 1999 to that in 2000?
Your answer should be very brief. 0.8. What is the ratio of the Aid flow (current US$) of Germany in 1999 to that in 2000?
Give a very brief answer. 0.88. What is the ratio of the Aid flow (current US$) in Italy in 1999 to that in 2000?
Give a very brief answer. 0.95. What is the ratio of the Aid flow (current US$) of Japan in 1999 to that in 2000?
Offer a very short reply. 1.38. What is the difference between the highest and the second highest Aid flow (current US$) of France?
Ensure brevity in your answer.  3.00e+04. What is the difference between the highest and the second highest Aid flow (current US$) in Japan?
Make the answer very short. 2.24e+06. What is the difference between the highest and the lowest Aid flow (current US$) in Germany?
Offer a terse response. 2.95e+06. What is the difference between the highest and the lowest Aid flow (current US$) of Italy?
Give a very brief answer. 6.40e+05. What is the difference between the highest and the lowest Aid flow (current US$) in Japan?
Provide a short and direct response. 8.09e+06. 